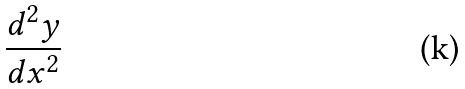<formula> <loc_0><loc_0><loc_500><loc_500>\frac { d ^ { 2 } y } { d x ^ { 2 } }</formula> 